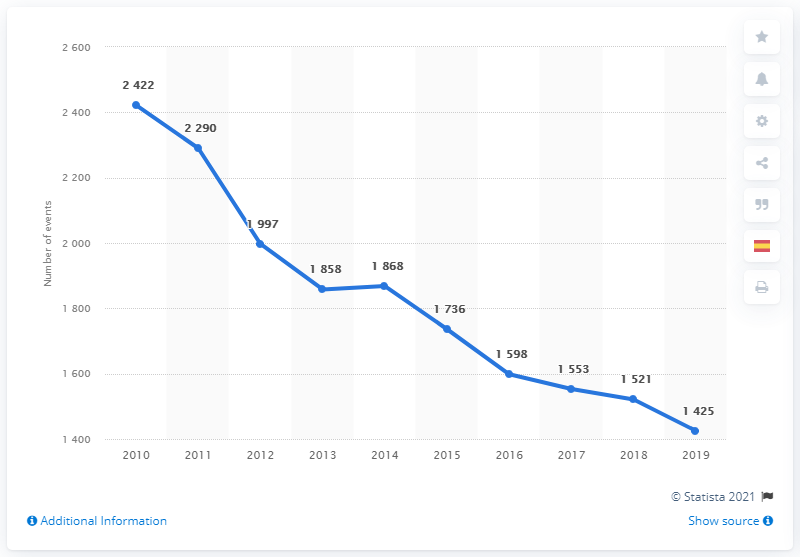List a handful of essential elements in this visual. The value of 1425 in 2019 is X. The year 2019 is nine years newer than 2010. 